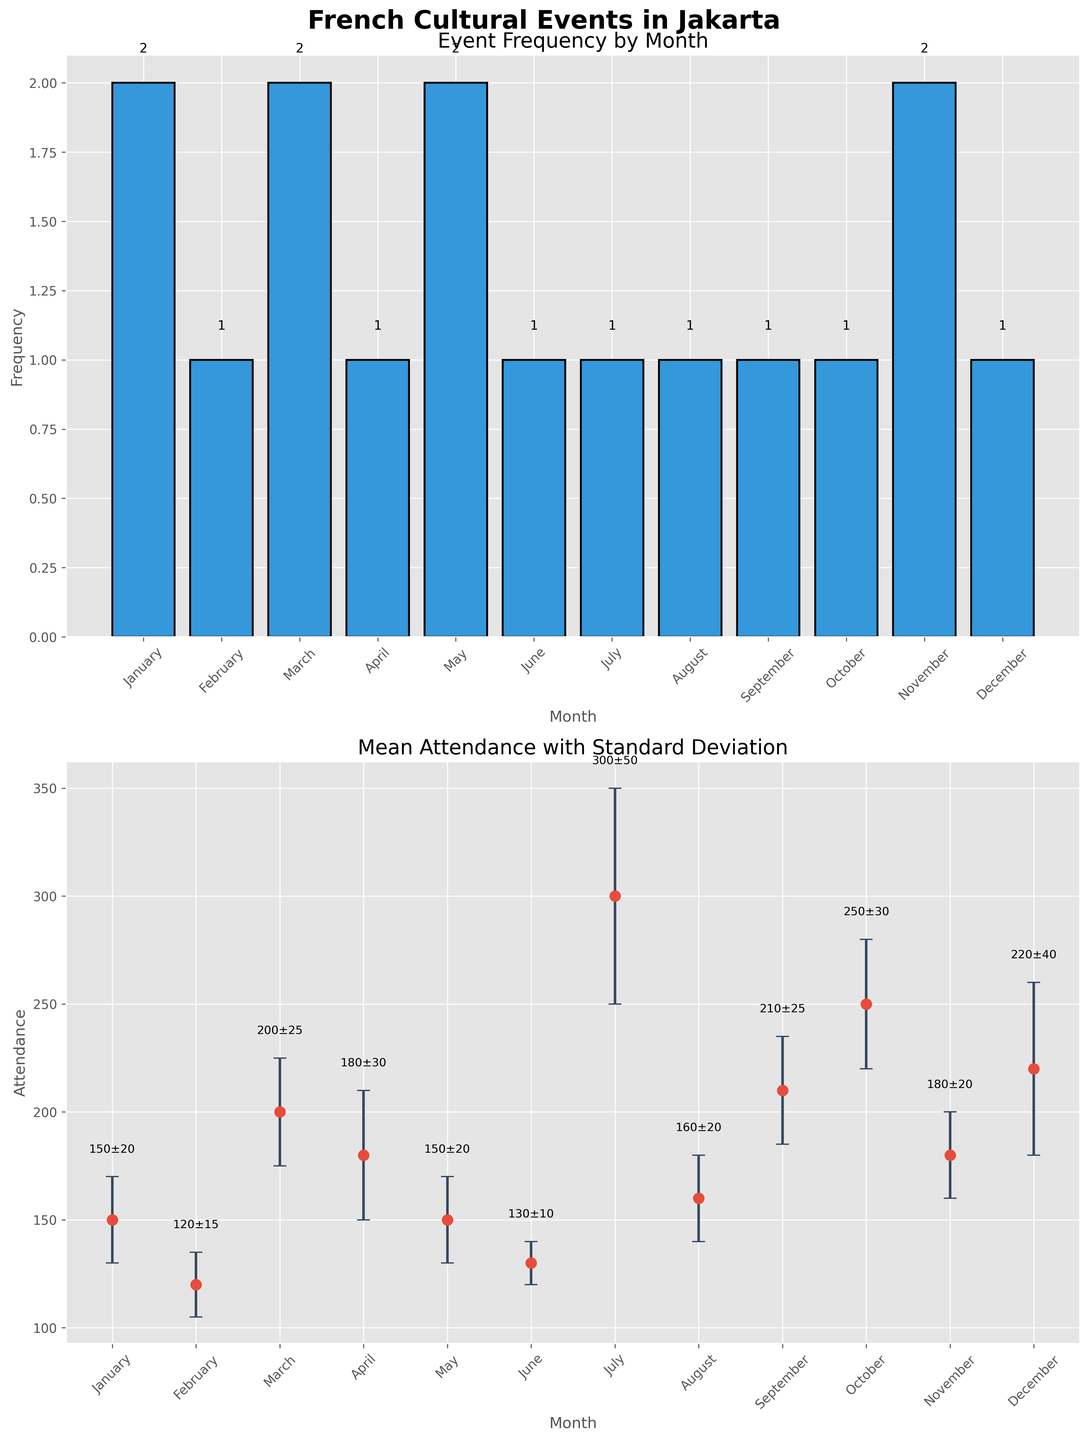what's the title of the overall figure? The title of the entire figure is displayed at the top in bold and large font. It reads "French Cultural Events in Jakarta".
Answer: French Cultural Events in Jakarta what is the frequency of events in November? Referring to the bar height for November in the first subplot, we see that it reaches up to 2. Therefore, the frequency for November is 2.
Answer: 2 which month has the highest mean attendance? In the second subplot, the month with the highest data point on the y-axis represents the highest mean attendance. July's marker is the highest, indicating a mean attendance of 300.
Answer: July what is the mean attendance for French Film Festival held in January along with its standard deviation? Looking at the error bars in the second subplot for January, the data point with its label reads "150±20," indicating a mean attendance of 150 and a standard deviation of 20.
Answer: 150±20 which event has the lowest mean attendance and in which month is it held? By examining the second subplot for the lowest data point on the y-axis, French Book Reading in June has the lowest mean attendance of 130.
Answer: French Book Reading, June in which month were French cultural events held twice? From the first subplot, observe the months with bars reaching up to 2. These are January, March, May, and November.
Answer: January, March, May, November how does the mean attendance with standard deviation for French Film Festival compare with the French Book Reading? In January, the mean attendance with standard deviation for French Film Festival is 150±20. In June, for French Book Reading, it is 130±10. Film Festival has a higher mean attendance both in mean and standard deviation.
Answer: Film Festival: 150±20, Book Reading: 130±10 what's the total frequency of events held throughout the year? Summing up all the frequencies from the first subplot, we get 2 + 1 + 2 + 1 + 2 + 1 + 1 + 1 + 1 + 1 + 2 + 1 = 16.
Answer: 16 compare the mean attendance for French Jazz Night in March and French Classical Music Evening in November? Looking at March and November data points in the second subplot, we see March (French Jazz Night) has mean attendance of 200 and November (French Classical Music Evening) has 180. March has higher mean attendance than November.
Answer: March: 200, November: 180 